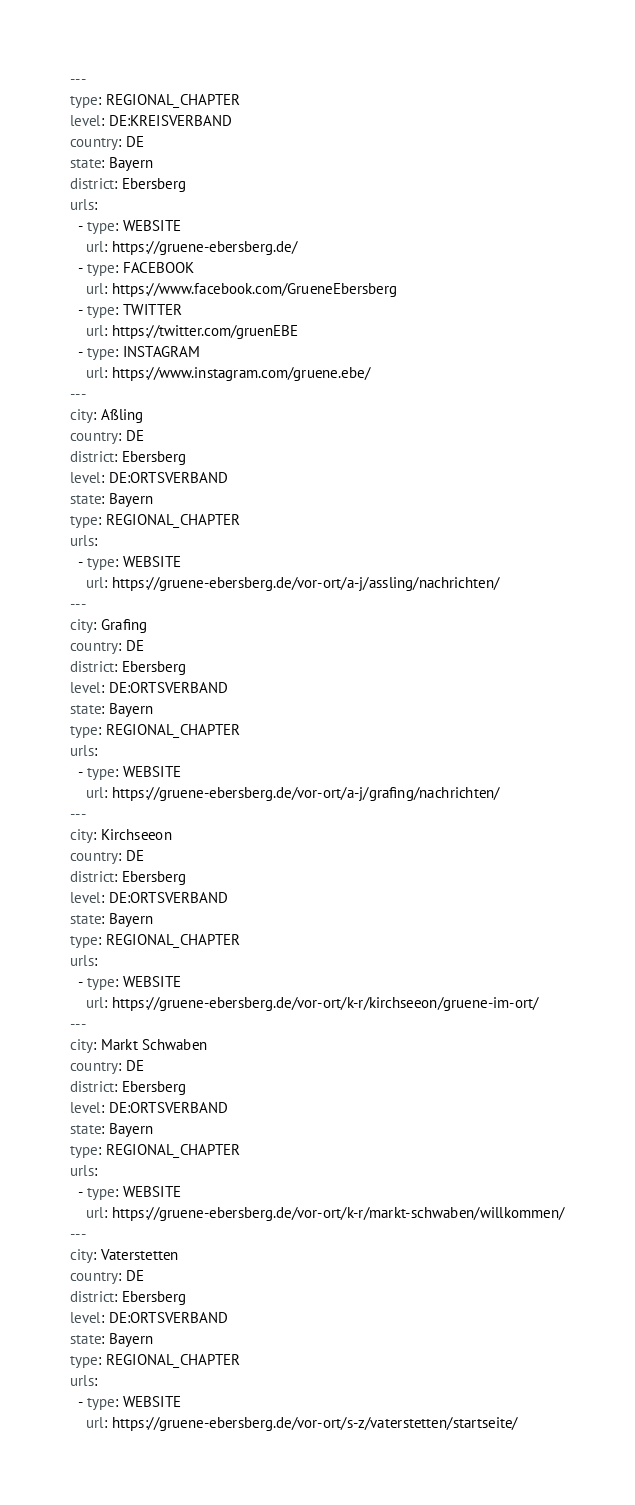Convert code to text. <code><loc_0><loc_0><loc_500><loc_500><_YAML_>---
type: REGIONAL_CHAPTER
level: DE:KREISVERBAND
country: DE
state: Bayern
district: Ebersberg
urls:
  - type: WEBSITE
    url: https://gruene-ebersberg.de/
  - type: FACEBOOK
    url: https://www.facebook.com/GrueneEbersberg
  - type: TWITTER
    url: https://twitter.com/gruenEBE
  - type: INSTAGRAM
    url: https://www.instagram.com/gruene.ebe/
---
city: Aßling
country: DE
district: Ebersberg
level: DE:ORTSVERBAND
state: Bayern
type: REGIONAL_CHAPTER
urls:
  - type: WEBSITE
    url: https://gruene-ebersberg.de/vor-ort/a-j/assling/nachrichten/
---
city: Grafing
country: DE
district: Ebersberg
level: DE:ORTSVERBAND
state: Bayern
type: REGIONAL_CHAPTER
urls:
  - type: WEBSITE
    url: https://gruene-ebersberg.de/vor-ort/a-j/grafing/nachrichten/
---
city: Kirchseeon
country: DE
district: Ebersberg
level: DE:ORTSVERBAND
state: Bayern
type: REGIONAL_CHAPTER
urls:
  - type: WEBSITE
    url: https://gruene-ebersberg.de/vor-ort/k-r/kirchseeon/gruene-im-ort/
---
city: Markt Schwaben
country: DE
district: Ebersberg
level: DE:ORTSVERBAND
state: Bayern
type: REGIONAL_CHAPTER
urls:
  - type: WEBSITE
    url: https://gruene-ebersberg.de/vor-ort/k-r/markt-schwaben/willkommen/
---
city: Vaterstetten
country: DE
district: Ebersberg
level: DE:ORTSVERBAND
state: Bayern
type: REGIONAL_CHAPTER
urls:
  - type: WEBSITE
    url: https://gruene-ebersberg.de/vor-ort/s-z/vaterstetten/startseite/
</code> 